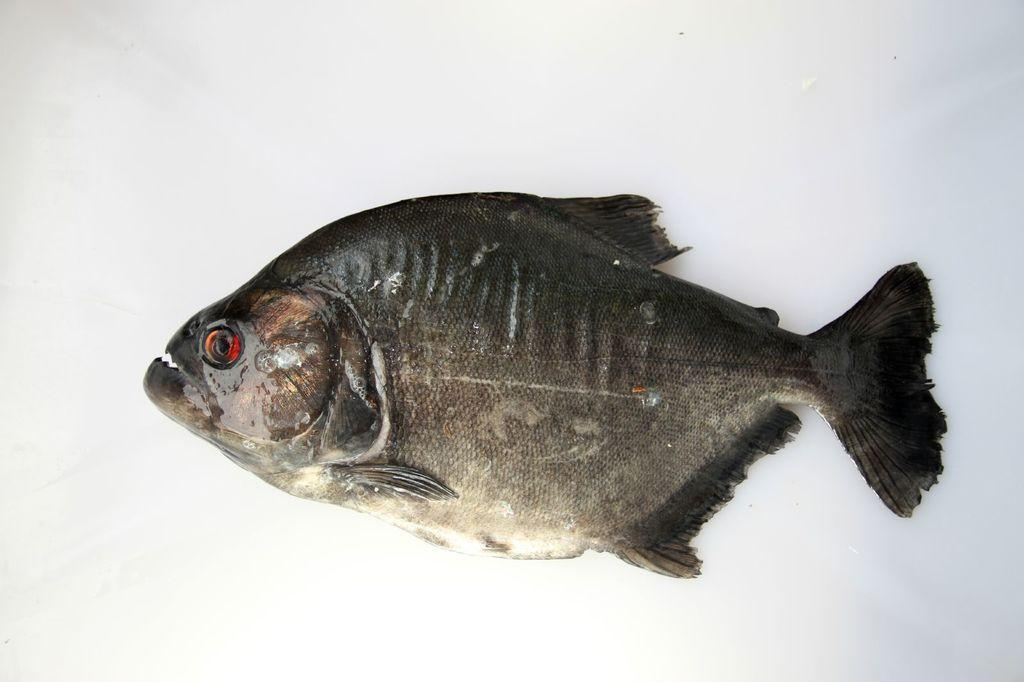What is the main subject of the image? There is a fish in the image. What color is the background of the image? The background of the image is white. Where is the crown placed in the image? There is no crown present in the image. What type of lamp is visible in the image? There is no lamp present in the image. 